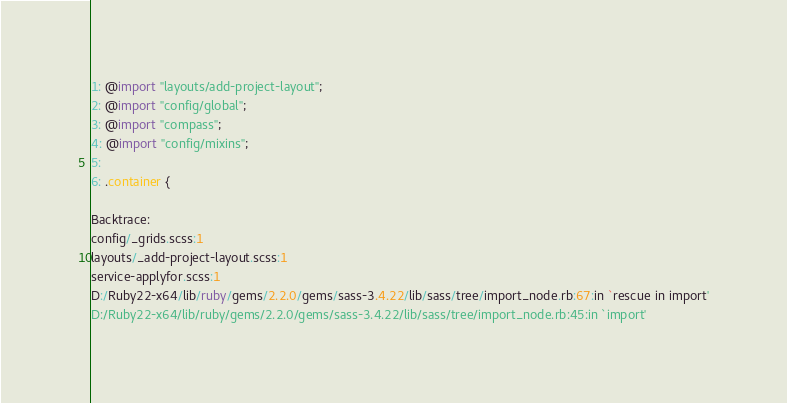<code> <loc_0><loc_0><loc_500><loc_500><_CSS_>
1: @import "layouts/add-project-layout";
2: @import "config/global";
3: @import "compass";
4: @import "config/mixins";
5: 
6: .container {

Backtrace:
config/_grids.scss:1
layouts/_add-project-layout.scss:1
service-applyfor.scss:1
D:/Ruby22-x64/lib/ruby/gems/2.2.0/gems/sass-3.4.22/lib/sass/tree/import_node.rb:67:in `rescue in import'
D:/Ruby22-x64/lib/ruby/gems/2.2.0/gems/sass-3.4.22/lib/sass/tree/import_node.rb:45:in `import'</code> 